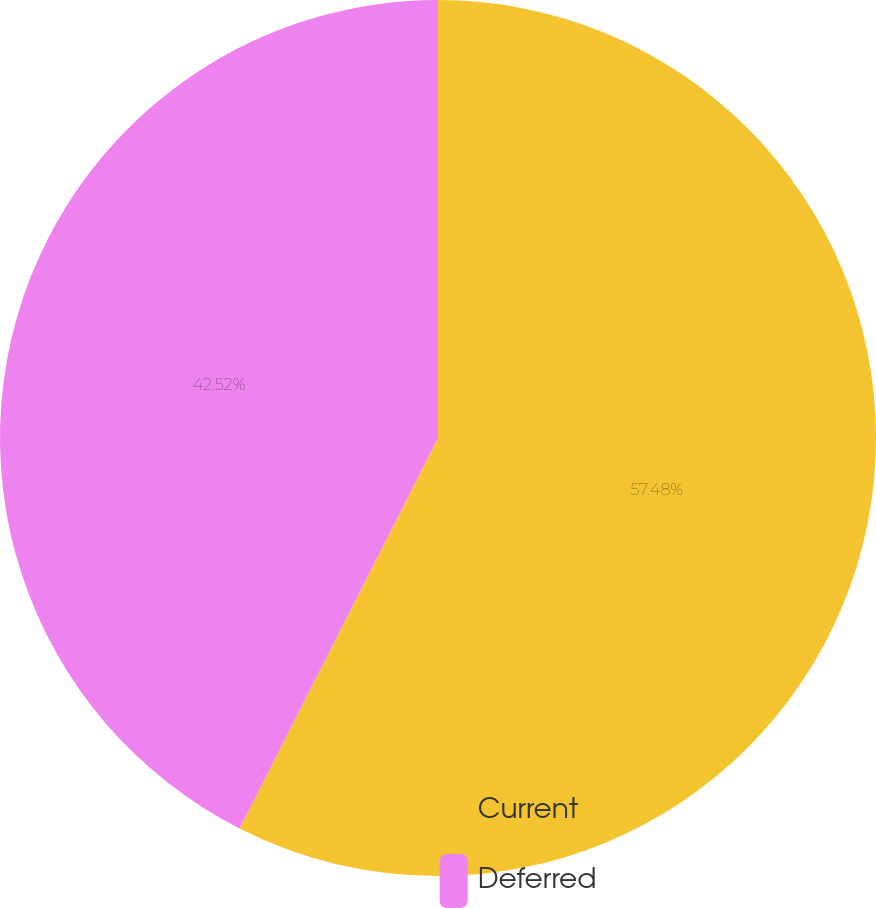Convert chart. <chart><loc_0><loc_0><loc_500><loc_500><pie_chart><fcel>Current<fcel>Deferred<nl><fcel>57.48%<fcel>42.52%<nl></chart> 